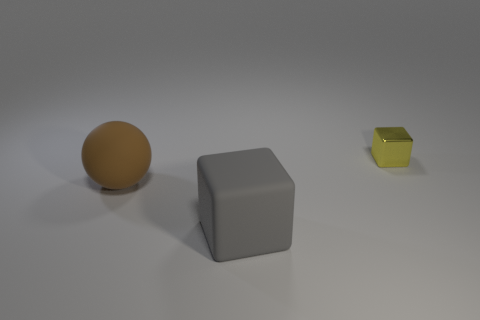Add 1 metal objects. How many objects exist? 4 Subtract all spheres. How many objects are left? 2 Add 3 tiny yellow metal blocks. How many tiny yellow metal blocks are left? 4 Add 2 large blue metal cylinders. How many large blue metal cylinders exist? 2 Subtract 0 red blocks. How many objects are left? 3 Subtract all large gray cubes. Subtract all large gray rubber objects. How many objects are left? 1 